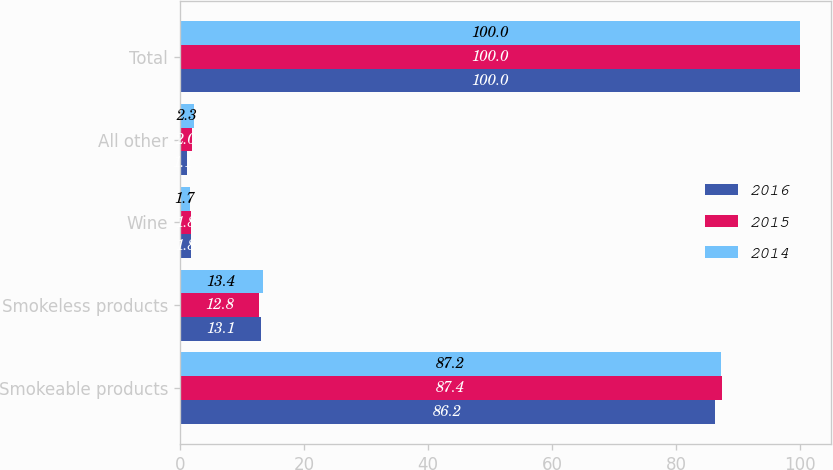Convert chart to OTSL. <chart><loc_0><loc_0><loc_500><loc_500><stacked_bar_chart><ecel><fcel>Smokeable products<fcel>Smokeless products<fcel>Wine<fcel>All other<fcel>Total<nl><fcel>2016<fcel>86.2<fcel>13.1<fcel>1.8<fcel>1.1<fcel>100<nl><fcel>2015<fcel>87.4<fcel>12.8<fcel>1.8<fcel>2<fcel>100<nl><fcel>2014<fcel>87.2<fcel>13.4<fcel>1.7<fcel>2.3<fcel>100<nl></chart> 